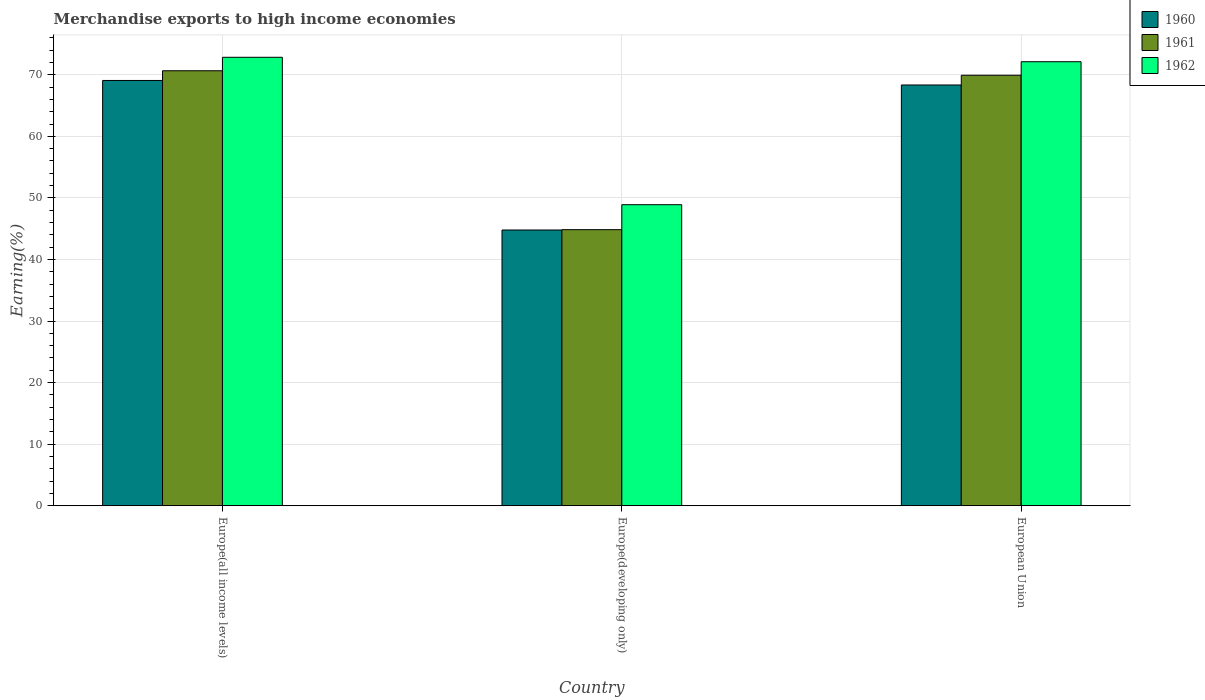How many different coloured bars are there?
Make the answer very short. 3. Are the number of bars on each tick of the X-axis equal?
Your answer should be very brief. Yes. How many bars are there on the 2nd tick from the left?
Give a very brief answer. 3. How many bars are there on the 1st tick from the right?
Offer a terse response. 3. What is the label of the 2nd group of bars from the left?
Give a very brief answer. Europe(developing only). What is the percentage of amount earned from merchandise exports in 1961 in European Union?
Your answer should be very brief. 69.93. Across all countries, what is the maximum percentage of amount earned from merchandise exports in 1960?
Offer a very short reply. 69.08. Across all countries, what is the minimum percentage of amount earned from merchandise exports in 1961?
Keep it short and to the point. 44.84. In which country was the percentage of amount earned from merchandise exports in 1962 maximum?
Your answer should be very brief. Europe(all income levels). In which country was the percentage of amount earned from merchandise exports in 1962 minimum?
Your answer should be very brief. Europe(developing only). What is the total percentage of amount earned from merchandise exports in 1961 in the graph?
Your answer should be very brief. 185.43. What is the difference between the percentage of amount earned from merchandise exports in 1962 in Europe(all income levels) and that in European Union?
Your answer should be compact. 0.72. What is the difference between the percentage of amount earned from merchandise exports in 1961 in European Union and the percentage of amount earned from merchandise exports in 1960 in Europe(all income levels)?
Ensure brevity in your answer.  0.85. What is the average percentage of amount earned from merchandise exports in 1962 per country?
Offer a terse response. 64.62. What is the difference between the percentage of amount earned from merchandise exports of/in 1961 and percentage of amount earned from merchandise exports of/in 1962 in Europe(developing only)?
Provide a short and direct response. -4.06. In how many countries, is the percentage of amount earned from merchandise exports in 1962 greater than 30 %?
Offer a terse response. 3. What is the ratio of the percentage of amount earned from merchandise exports in 1960 in Europe(all income levels) to that in Europe(developing only)?
Provide a succinct answer. 1.54. Is the percentage of amount earned from merchandise exports in 1962 in Europe(all income levels) less than that in European Union?
Ensure brevity in your answer.  No. What is the difference between the highest and the second highest percentage of amount earned from merchandise exports in 1961?
Offer a very short reply. -25.08. What is the difference between the highest and the lowest percentage of amount earned from merchandise exports in 1962?
Your answer should be very brief. 23.94. In how many countries, is the percentage of amount earned from merchandise exports in 1960 greater than the average percentage of amount earned from merchandise exports in 1960 taken over all countries?
Provide a succinct answer. 2. What does the 3rd bar from the right in Europe(developing only) represents?
Your answer should be very brief. 1960. Is it the case that in every country, the sum of the percentage of amount earned from merchandise exports in 1960 and percentage of amount earned from merchandise exports in 1962 is greater than the percentage of amount earned from merchandise exports in 1961?
Your answer should be compact. Yes. How many bars are there?
Offer a very short reply. 9. Are all the bars in the graph horizontal?
Your answer should be very brief. No. How many countries are there in the graph?
Your answer should be very brief. 3. Are the values on the major ticks of Y-axis written in scientific E-notation?
Keep it short and to the point. No. Does the graph contain grids?
Your response must be concise. Yes. How are the legend labels stacked?
Provide a succinct answer. Vertical. What is the title of the graph?
Keep it short and to the point. Merchandise exports to high income economies. Does "1969" appear as one of the legend labels in the graph?
Keep it short and to the point. No. What is the label or title of the Y-axis?
Offer a very short reply. Earning(%). What is the Earning(%) in 1960 in Europe(all income levels)?
Offer a terse response. 69.08. What is the Earning(%) of 1961 in Europe(all income levels)?
Give a very brief answer. 70.66. What is the Earning(%) in 1962 in Europe(all income levels)?
Offer a very short reply. 72.84. What is the Earning(%) in 1960 in Europe(developing only)?
Offer a very short reply. 44.79. What is the Earning(%) of 1961 in Europe(developing only)?
Provide a short and direct response. 44.84. What is the Earning(%) in 1962 in Europe(developing only)?
Your answer should be very brief. 48.9. What is the Earning(%) in 1960 in European Union?
Your answer should be compact. 68.35. What is the Earning(%) in 1961 in European Union?
Give a very brief answer. 69.93. What is the Earning(%) of 1962 in European Union?
Ensure brevity in your answer.  72.13. Across all countries, what is the maximum Earning(%) in 1960?
Provide a short and direct response. 69.08. Across all countries, what is the maximum Earning(%) of 1961?
Provide a succinct answer. 70.66. Across all countries, what is the maximum Earning(%) in 1962?
Give a very brief answer. 72.84. Across all countries, what is the minimum Earning(%) in 1960?
Ensure brevity in your answer.  44.79. Across all countries, what is the minimum Earning(%) of 1961?
Keep it short and to the point. 44.84. Across all countries, what is the minimum Earning(%) of 1962?
Offer a terse response. 48.9. What is the total Earning(%) of 1960 in the graph?
Ensure brevity in your answer.  182.22. What is the total Earning(%) in 1961 in the graph?
Your answer should be very brief. 185.43. What is the total Earning(%) of 1962 in the graph?
Keep it short and to the point. 193.87. What is the difference between the Earning(%) in 1960 in Europe(all income levels) and that in Europe(developing only)?
Your answer should be compact. 24.29. What is the difference between the Earning(%) in 1961 in Europe(all income levels) and that in Europe(developing only)?
Provide a short and direct response. 25.81. What is the difference between the Earning(%) in 1962 in Europe(all income levels) and that in Europe(developing only)?
Offer a terse response. 23.94. What is the difference between the Earning(%) of 1960 in Europe(all income levels) and that in European Union?
Provide a short and direct response. 0.73. What is the difference between the Earning(%) of 1961 in Europe(all income levels) and that in European Union?
Make the answer very short. 0.73. What is the difference between the Earning(%) in 1962 in Europe(all income levels) and that in European Union?
Offer a terse response. 0.72. What is the difference between the Earning(%) of 1960 in Europe(developing only) and that in European Union?
Give a very brief answer. -23.56. What is the difference between the Earning(%) of 1961 in Europe(developing only) and that in European Union?
Make the answer very short. -25.08. What is the difference between the Earning(%) in 1962 in Europe(developing only) and that in European Union?
Make the answer very short. -23.22. What is the difference between the Earning(%) of 1960 in Europe(all income levels) and the Earning(%) of 1961 in Europe(developing only)?
Your answer should be compact. 24.24. What is the difference between the Earning(%) of 1960 in Europe(all income levels) and the Earning(%) of 1962 in Europe(developing only)?
Ensure brevity in your answer.  20.18. What is the difference between the Earning(%) in 1961 in Europe(all income levels) and the Earning(%) in 1962 in Europe(developing only)?
Give a very brief answer. 21.76. What is the difference between the Earning(%) of 1960 in Europe(all income levels) and the Earning(%) of 1961 in European Union?
Keep it short and to the point. -0.85. What is the difference between the Earning(%) in 1960 in Europe(all income levels) and the Earning(%) in 1962 in European Union?
Provide a succinct answer. -3.04. What is the difference between the Earning(%) of 1961 in Europe(all income levels) and the Earning(%) of 1962 in European Union?
Ensure brevity in your answer.  -1.47. What is the difference between the Earning(%) in 1960 in Europe(developing only) and the Earning(%) in 1961 in European Union?
Offer a terse response. -25.14. What is the difference between the Earning(%) in 1960 in Europe(developing only) and the Earning(%) in 1962 in European Union?
Keep it short and to the point. -27.34. What is the difference between the Earning(%) in 1961 in Europe(developing only) and the Earning(%) in 1962 in European Union?
Give a very brief answer. -27.28. What is the average Earning(%) in 1960 per country?
Provide a short and direct response. 60.74. What is the average Earning(%) of 1961 per country?
Offer a terse response. 61.81. What is the average Earning(%) in 1962 per country?
Offer a very short reply. 64.62. What is the difference between the Earning(%) in 1960 and Earning(%) in 1961 in Europe(all income levels)?
Keep it short and to the point. -1.58. What is the difference between the Earning(%) in 1960 and Earning(%) in 1962 in Europe(all income levels)?
Offer a very short reply. -3.76. What is the difference between the Earning(%) in 1961 and Earning(%) in 1962 in Europe(all income levels)?
Keep it short and to the point. -2.19. What is the difference between the Earning(%) of 1960 and Earning(%) of 1961 in Europe(developing only)?
Ensure brevity in your answer.  -0.06. What is the difference between the Earning(%) in 1960 and Earning(%) in 1962 in Europe(developing only)?
Give a very brief answer. -4.11. What is the difference between the Earning(%) of 1961 and Earning(%) of 1962 in Europe(developing only)?
Your answer should be very brief. -4.06. What is the difference between the Earning(%) in 1960 and Earning(%) in 1961 in European Union?
Offer a terse response. -1.58. What is the difference between the Earning(%) of 1960 and Earning(%) of 1962 in European Union?
Give a very brief answer. -3.78. What is the difference between the Earning(%) of 1961 and Earning(%) of 1962 in European Union?
Ensure brevity in your answer.  -2.2. What is the ratio of the Earning(%) in 1960 in Europe(all income levels) to that in Europe(developing only)?
Provide a succinct answer. 1.54. What is the ratio of the Earning(%) in 1961 in Europe(all income levels) to that in Europe(developing only)?
Give a very brief answer. 1.58. What is the ratio of the Earning(%) in 1962 in Europe(all income levels) to that in Europe(developing only)?
Your answer should be compact. 1.49. What is the ratio of the Earning(%) in 1960 in Europe(all income levels) to that in European Union?
Offer a terse response. 1.01. What is the ratio of the Earning(%) of 1961 in Europe(all income levels) to that in European Union?
Keep it short and to the point. 1.01. What is the ratio of the Earning(%) in 1962 in Europe(all income levels) to that in European Union?
Provide a succinct answer. 1.01. What is the ratio of the Earning(%) in 1960 in Europe(developing only) to that in European Union?
Offer a very short reply. 0.66. What is the ratio of the Earning(%) in 1961 in Europe(developing only) to that in European Union?
Offer a terse response. 0.64. What is the ratio of the Earning(%) in 1962 in Europe(developing only) to that in European Union?
Your answer should be very brief. 0.68. What is the difference between the highest and the second highest Earning(%) of 1960?
Provide a succinct answer. 0.73. What is the difference between the highest and the second highest Earning(%) in 1961?
Give a very brief answer. 0.73. What is the difference between the highest and the second highest Earning(%) of 1962?
Provide a short and direct response. 0.72. What is the difference between the highest and the lowest Earning(%) in 1960?
Provide a succinct answer. 24.29. What is the difference between the highest and the lowest Earning(%) of 1961?
Your answer should be compact. 25.81. What is the difference between the highest and the lowest Earning(%) of 1962?
Offer a very short reply. 23.94. 